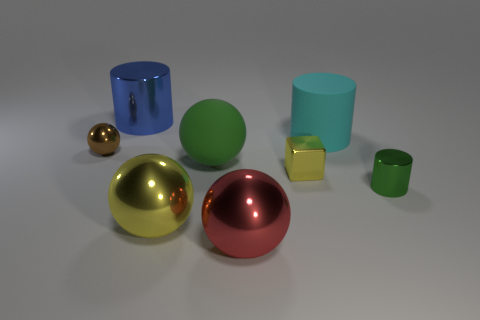Subtract all blue shiny cylinders. How many cylinders are left? 2 Add 1 tiny shiny things. How many objects exist? 9 Subtract all yellow balls. How many balls are left? 3 Subtract 2 cylinders. How many cylinders are left? 1 Subtract 1 red balls. How many objects are left? 7 Subtract all cubes. How many objects are left? 7 Subtract all cyan balls. Subtract all yellow cubes. How many balls are left? 4 Subtract all cylinders. Subtract all large metallic objects. How many objects are left? 2 Add 2 large red shiny things. How many large red shiny things are left? 3 Add 5 matte balls. How many matte balls exist? 6 